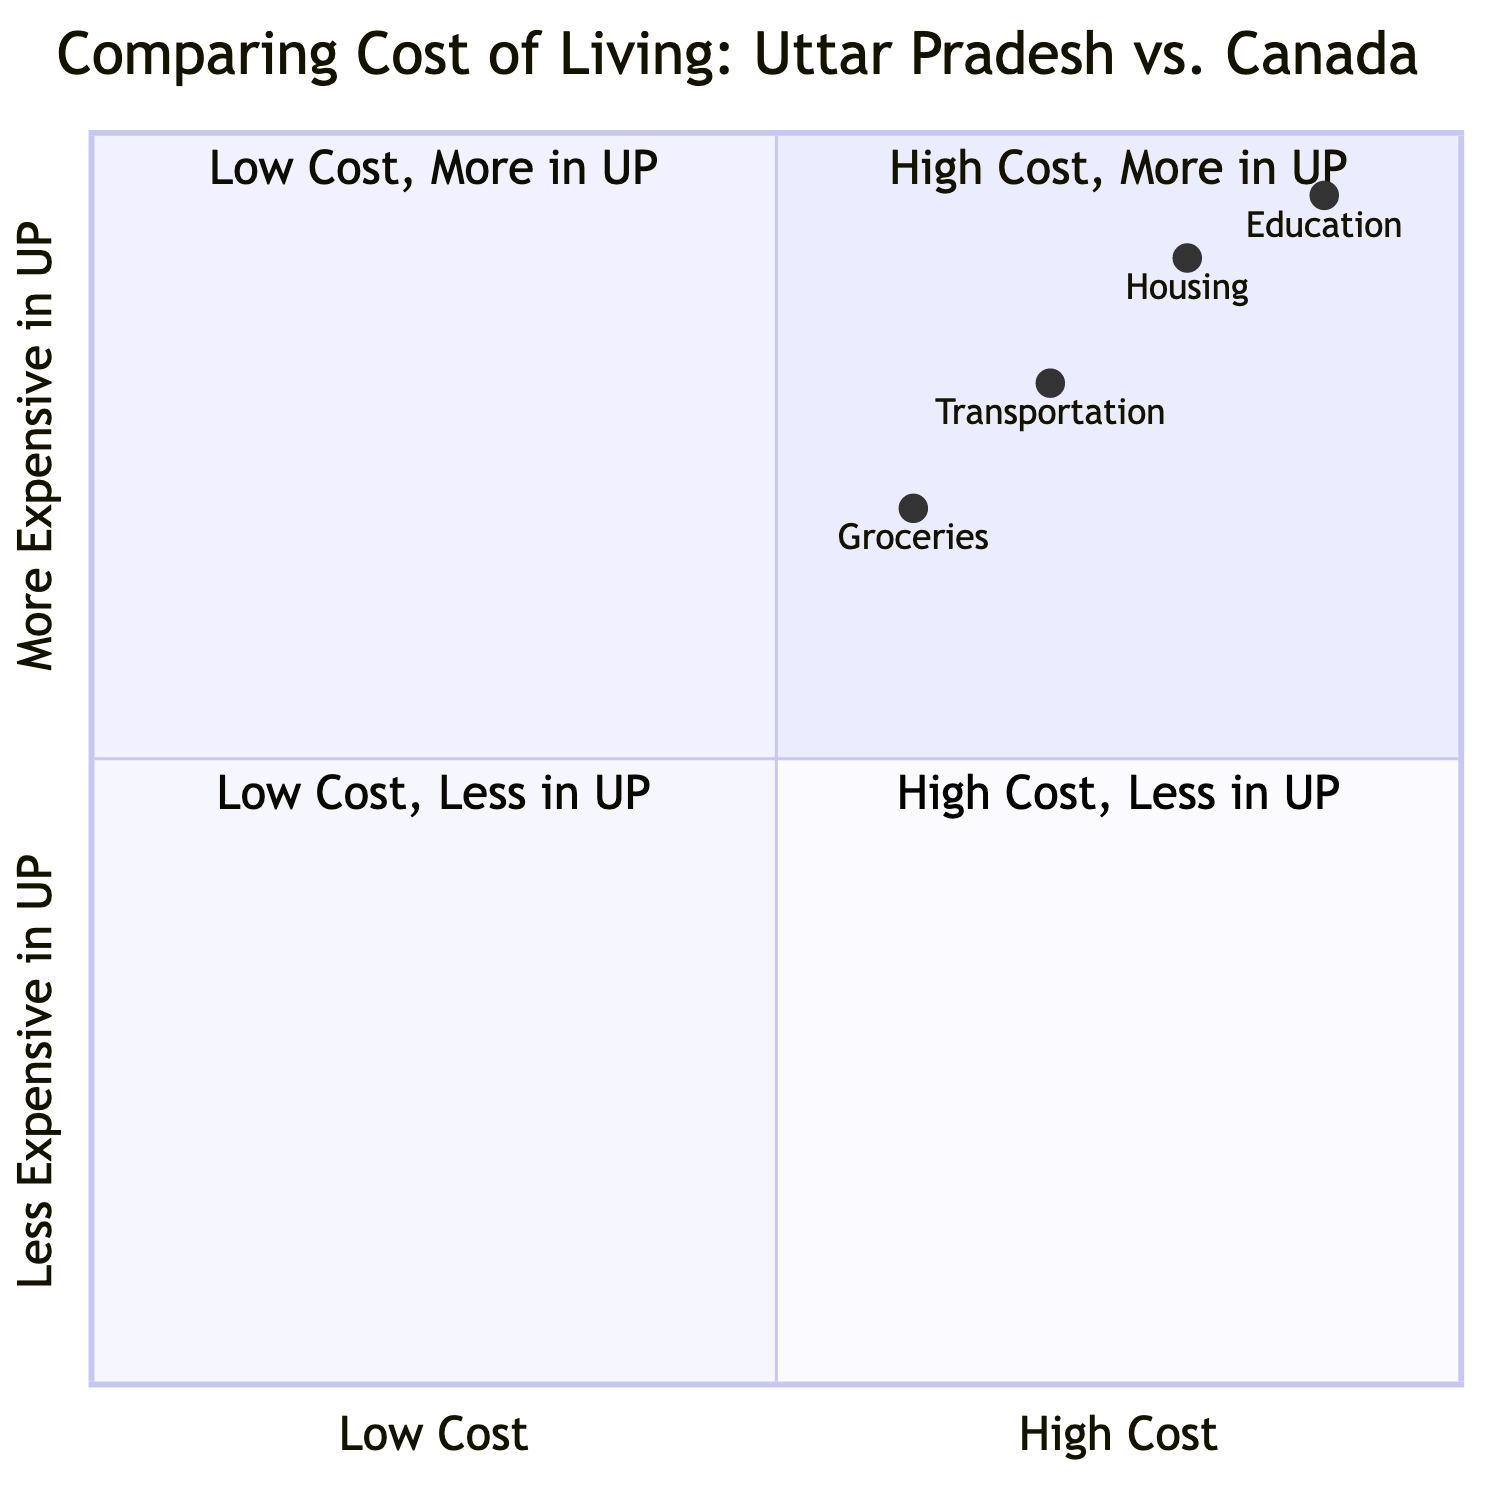What is the average monthly rent for a 2BHK in Uttar Pradesh? The average monthly rent for a 2BHK in Uttar Pradesh is shown directly in the data as "$200".
Answer: $200 What is the average price per square foot for Housing in Canada? The average price per square foot for Housing in Canada is directly provided in the data as "$400".
Answer: $400 Which category has the highest costs represented in the quadrant chart? Analyzing the positioning of the points in the chart, "Education" appears in quadrant 1 (high cost, more expensive in UP), indicating it has the highest costs compared to the other categories.
Answer: Education How much does a monthly public transport pass cost in Uttar Pradesh? The diagram indicates the cost of a monthly public transport pass in Uttar Pradesh as "$10". This is a direct data point.
Answer: $10 Which category is represented in quadrant 4? The quadrant chart shows "Transportation" is placed in quadrant 4 (high cost, less expensive in UP), indicating its position among the others.
Answer: Transportation What is the ratio of average monthly rent between Canada and Uttar Pradesh? The average monthly rent in Canada is $1200 and in Uttar Pradesh is $200. The ratio is 1200:200, which simplifies to 6:1.
Answer: 6:1 Which has a more significant cost difference, Groceries or Housing? Looking at the costs in the chart, Groceries indicates a smaller difference ($2 - $0.80 for rice) compared to Housing ($1200 - $200), making Housing the category with the larger discrepancy.
Answer: Housing In which quadrant is Groceries located? The data for Groceries places it in quadrant 2 (low cost, more expensive in UP), as it is shown to be cheaper in Uttar Pradesh compared to Canada.
Answer: Quadrant 2 How much does a Kg of Rice cost in Canada? The cost of a Kg of Rice in Canada is indicated in the data as "$2", providing a straightforward answer to the question.
Answer: $2 